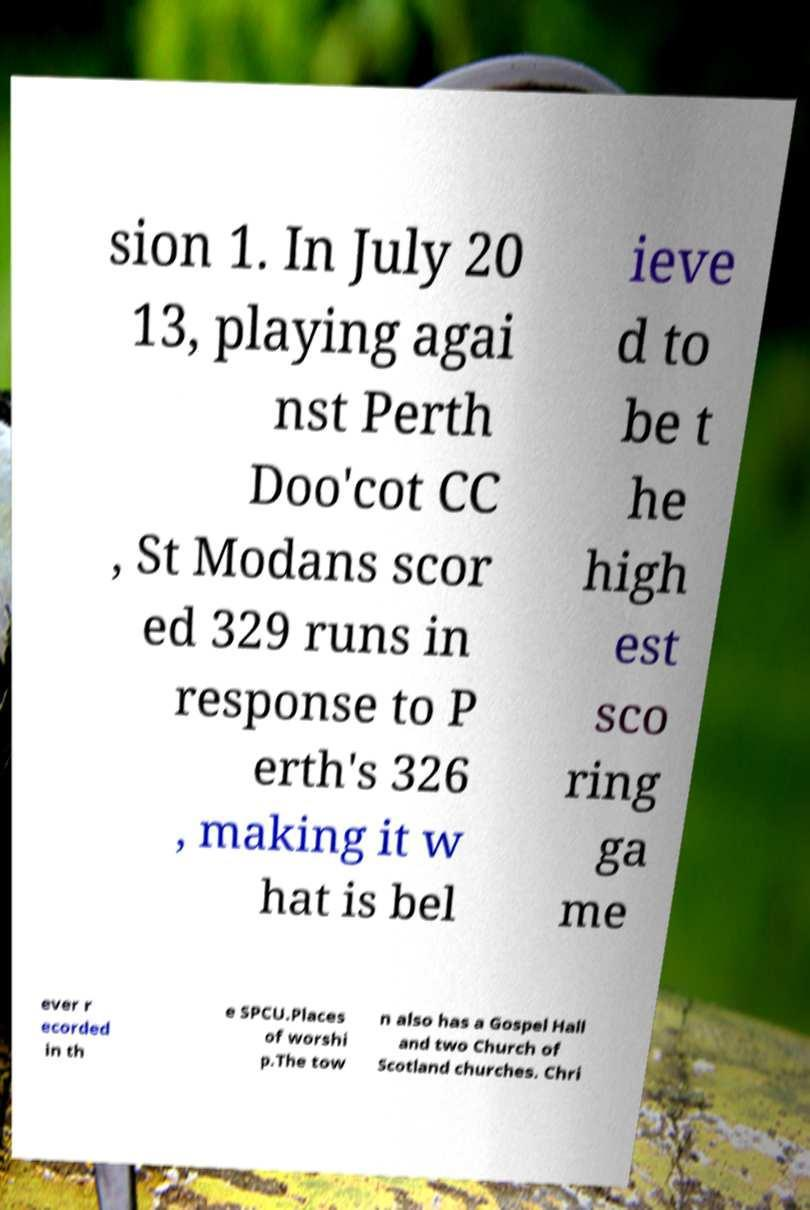I need the written content from this picture converted into text. Can you do that? sion 1. In July 20 13, playing agai nst Perth Doo'cot CC , St Modans scor ed 329 runs in response to P erth's 326 , making it w hat is bel ieve d to be t he high est sco ring ga me ever r ecorded in th e SPCU.Places of worshi p.The tow n also has a Gospel Hall and two Church of Scotland churches. Chri 